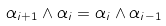Convert formula to latex. <formula><loc_0><loc_0><loc_500><loc_500>\alpha _ { i + 1 } \wedge \alpha _ { i } = \alpha _ { i } \wedge \alpha _ { i - 1 }</formula> 